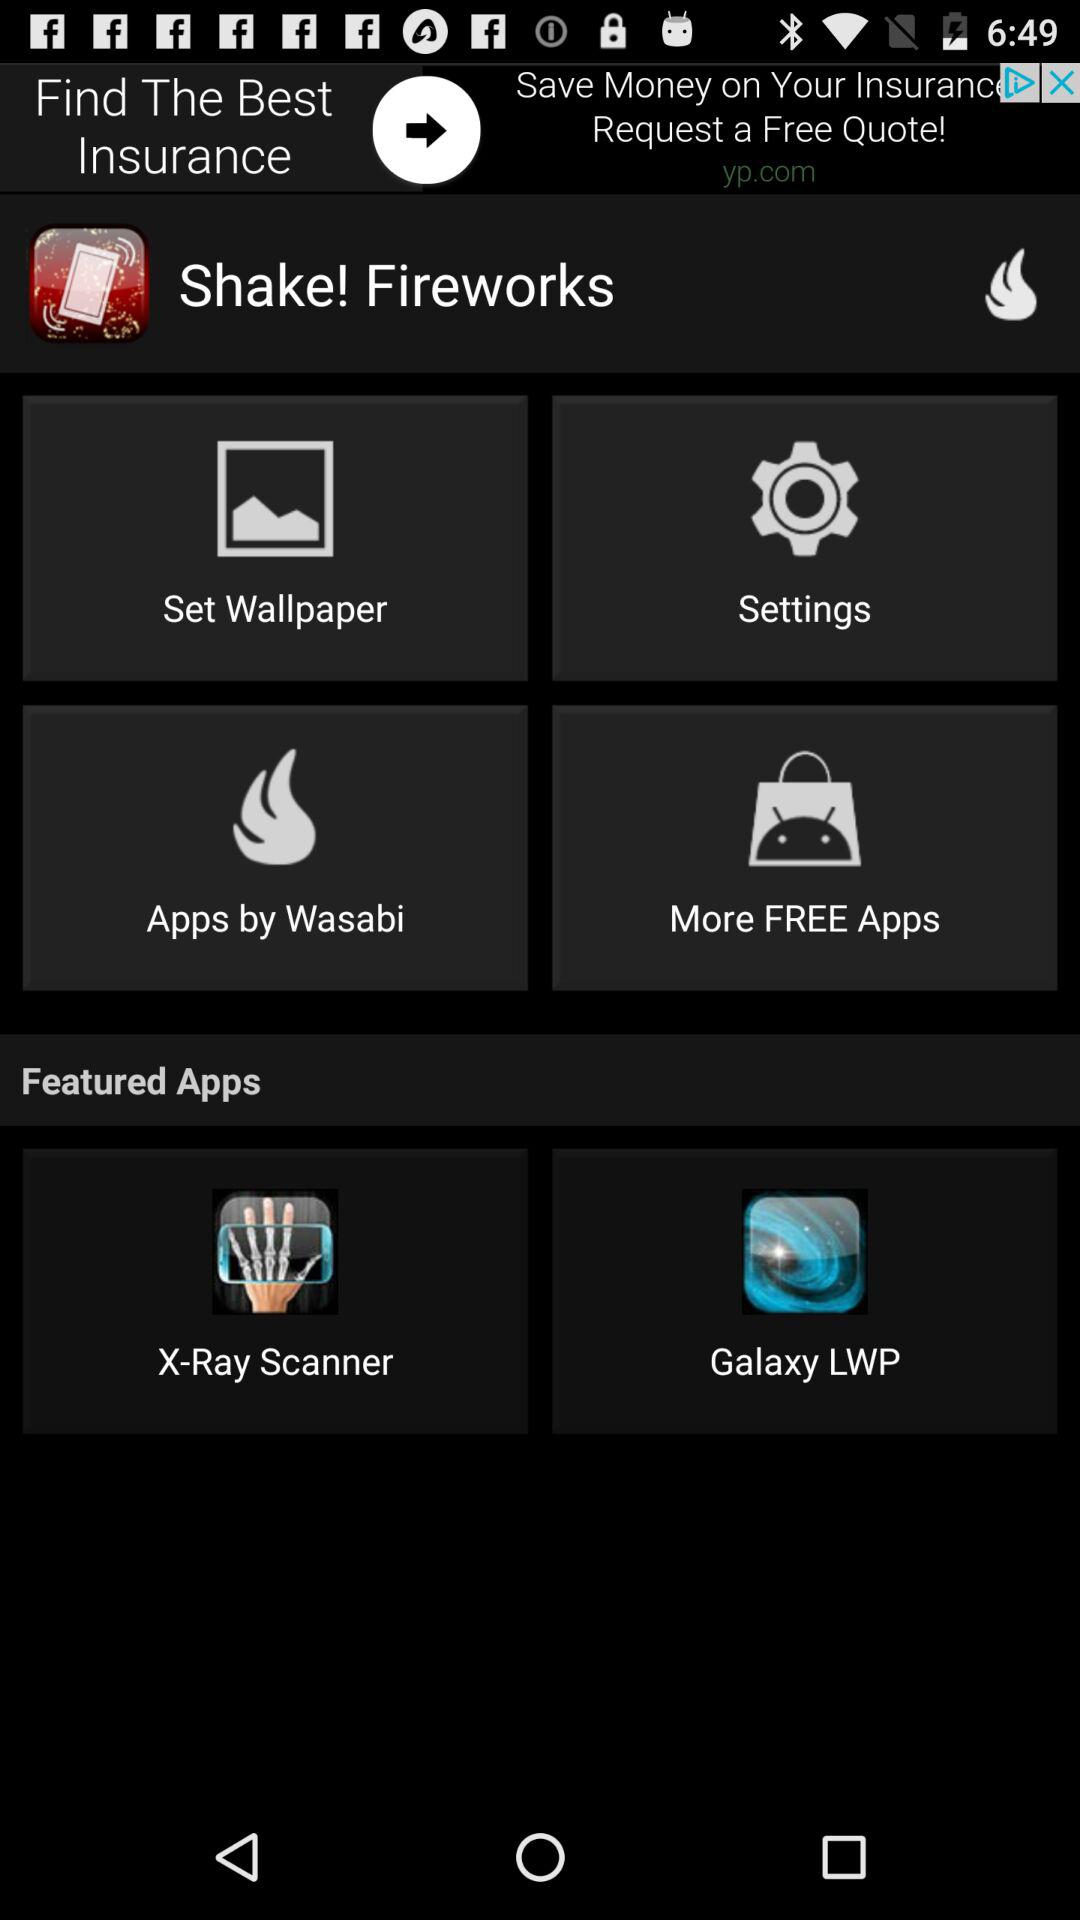What are the featured apps? The featured apps are "X-Ray Scanner" and "Galaxy LWP". 